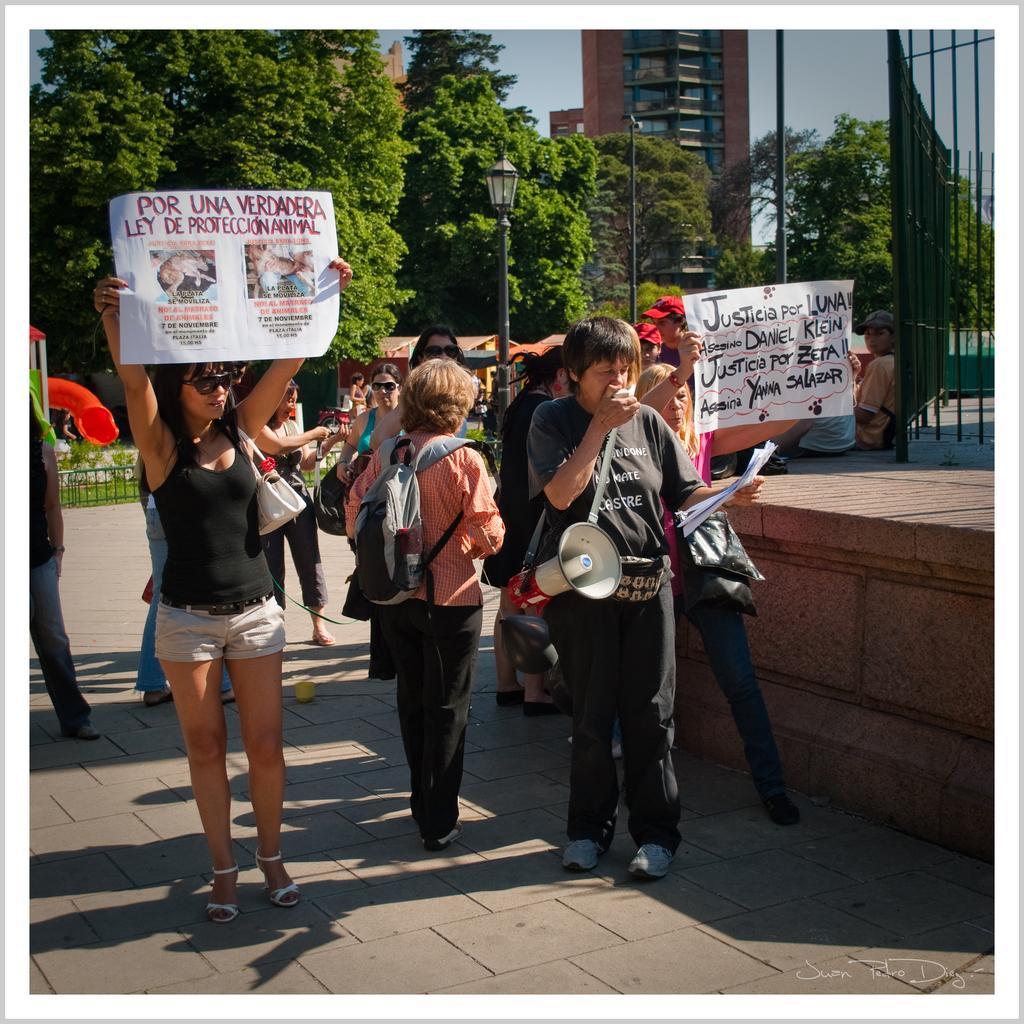Could you give a brief overview of what you see in this image? In this image we can see persons standing on the ground and holding advertisements, bags, speakers and papers in their hands. In the background we can see street poles, street lights, grill, trees, buildings and sky. 